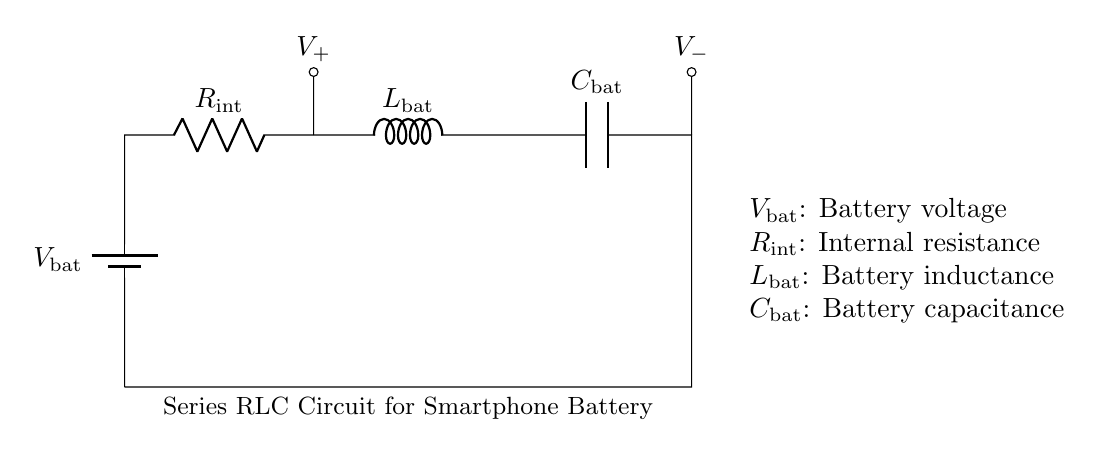What is the total number of components in the circuit? The circuit contains four components: a battery, a resistor, an inductor, and a capacitor. Each of these components is visible and labeled in the diagram.
Answer: four What is the function of the inductor in this circuit? The inductor's primary function is to store energy in a magnetic field when current flows through it, which can affect the transient response and energy discharge rates of the battery.
Answer: store energy What is the internal resistance of the battery likely to affect? The internal resistance mainly affects the efficiency of the battery discharge by causing voltage drops when current flows, leading to energy loss in the form of heat.
Answer: efficiency What happens to the voltage across the capacitor when the battery discharges? As the battery discharges, the voltage across the capacitor typically increases until it reaches the maximum charge allowed by the circuit's configuration and the component values.
Answer: increases What distinguishes this circuit as a series RLC circuit? This circuit is distinguished as a series RLC circuit because the resistor, inductor, and capacitor are all connected in a single, continuous path, allowing current to flow through each component sequentially.
Answer: series connection What is the role of the battery voltage in this circuit? The battery voltage provides the necessary potential difference to drive current through the circuit, influencing how the other components behave during the discharge process.
Answer: drive current 